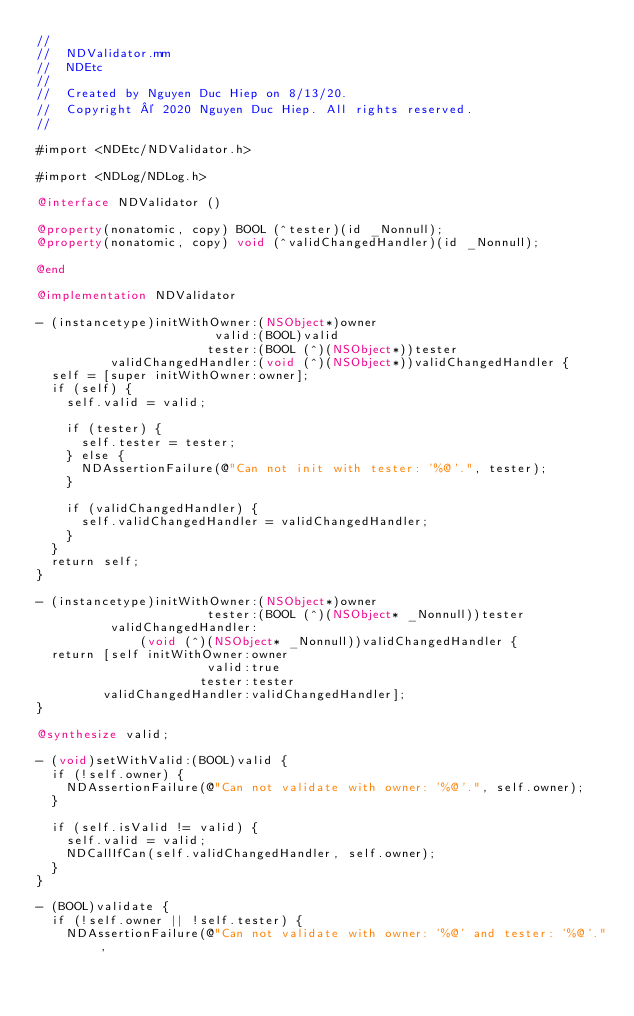Convert code to text. <code><loc_0><loc_0><loc_500><loc_500><_ObjectiveC_>//
//  NDValidator.mm
//  NDEtc
//
//  Created by Nguyen Duc Hiep on 8/13/20.
//  Copyright © 2020 Nguyen Duc Hiep. All rights reserved.
//

#import <NDEtc/NDValidator.h>

#import <NDLog/NDLog.h>

@interface NDValidator ()

@property(nonatomic, copy) BOOL (^tester)(id _Nonnull);
@property(nonatomic, copy) void (^validChangedHandler)(id _Nonnull);

@end

@implementation NDValidator

- (instancetype)initWithOwner:(NSObject*)owner
                        valid:(BOOL)valid
                       tester:(BOOL (^)(NSObject*))tester
          validChangedHandler:(void (^)(NSObject*))validChangedHandler {
  self = [super initWithOwner:owner];
  if (self) {
    self.valid = valid;

    if (tester) {
      self.tester = tester;
    } else {
      NDAssertionFailure(@"Can not init with tester: '%@'.", tester);
    }

    if (validChangedHandler) {
      self.validChangedHandler = validChangedHandler;
    }
  }
  return self;
}

- (instancetype)initWithOwner:(NSObject*)owner
                       tester:(BOOL (^)(NSObject* _Nonnull))tester
          validChangedHandler:
              (void (^)(NSObject* _Nonnull))validChangedHandler {
  return [self initWithOwner:owner
                       valid:true
                      tester:tester
         validChangedHandler:validChangedHandler];
}

@synthesize valid;

- (void)setWithValid:(BOOL)valid {
  if (!self.owner) {
    NDAssertionFailure(@"Can not validate with owner: '%@'.", self.owner);
  }

  if (self.isValid != valid) {
    self.valid = valid;
    NDCallIfCan(self.validChangedHandler, self.owner);
  }
}

- (BOOL)validate {
  if (!self.owner || !self.tester) {
    NDAssertionFailure(@"Can not validate with owner: '%@' and tester: '%@'.",</code> 